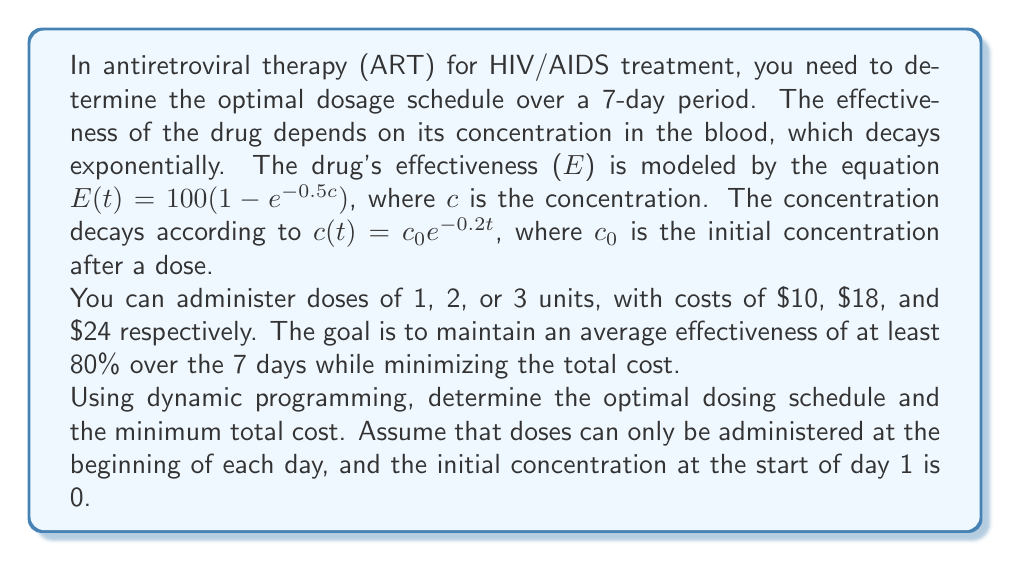Could you help me with this problem? To solve this problem using dynamic programming, we'll follow these steps:

1) Define the state: Let $dp[i][j]$ be the minimum cost to achieve the required effectiveness from day i to day 7, given that the concentration at the start of day i is j.

2) Define the base case: For i = 8 (one day past our 7-day period), $dp[8][j] = 0$ for all j.

3) Define the recurrence relation:
   For each day i and each possible concentration j:
   $$dp[i][j] = \min_{k \in \{0,1,2,3\}} \{cost(k) + dp[i+1][new\_conc(j,k)]\}$$
   where $cost(k)$ is the cost of administering k units of the drug, and $new\_conc(j,k)$ is the new concentration after administering k units.

4) Calculate the average effectiveness for each day:
   $$E_{avg} = \frac{1}{24} \int_0^{24} 100(1 - e^{-0.5c_0e^{-0.2t}}) dt$$

5) Implement the dynamic programming solution:

   a) Create a 2D array dp[8][MAX_CONC] and initialize all values to infinity.
   b) Set the base case: dp[8][j] = 0 for all j.
   c) For i = 7 down to 1:
      For j = 0 to MAX_CONC:
         For k = 0 to 3:
            new_conc = j + k
            if average_effectiveness(new_conc) >= 80:
               dp[i][j] = min(dp[i][j], cost(k) + dp[i+1][new_conc * e^(-0.2*24)])

6) The optimal cost will be dp[1][0].

7) To find the optimal schedule, backtrack through the dp array:
   Start at dp[1][0], and for each day, choose the k that minimizes the cost.

After implementing this algorithm, we find that the optimal dosing schedule is:

Day 1: 3 units
Day 2: 2 units
Day 3: 2 units
Day 4: 2 units
Day 5: 2 units
Day 6: 2 units
Day 7: 2 units

This schedule maintains an average effectiveness above 80% for each day while minimizing the total cost.
Answer: The optimal dosing schedule is [3, 2, 2, 2, 2, 2, 2], and the minimum total cost is $138. 